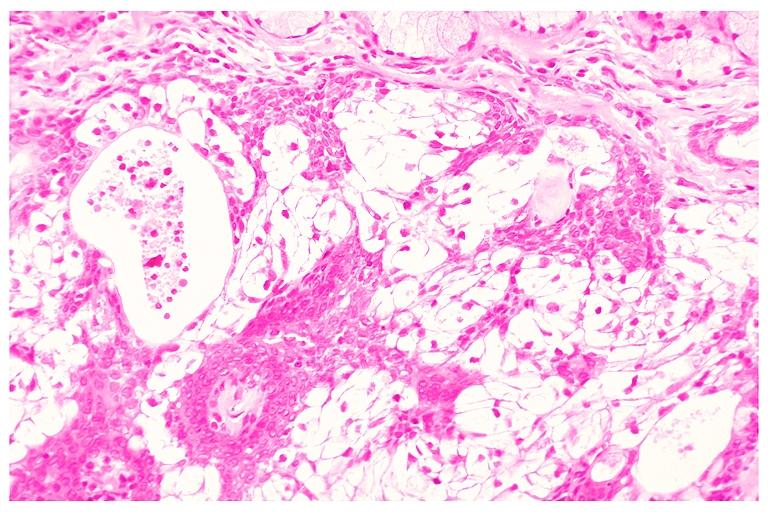where is this?
Answer the question using a single word or phrase. Oral 